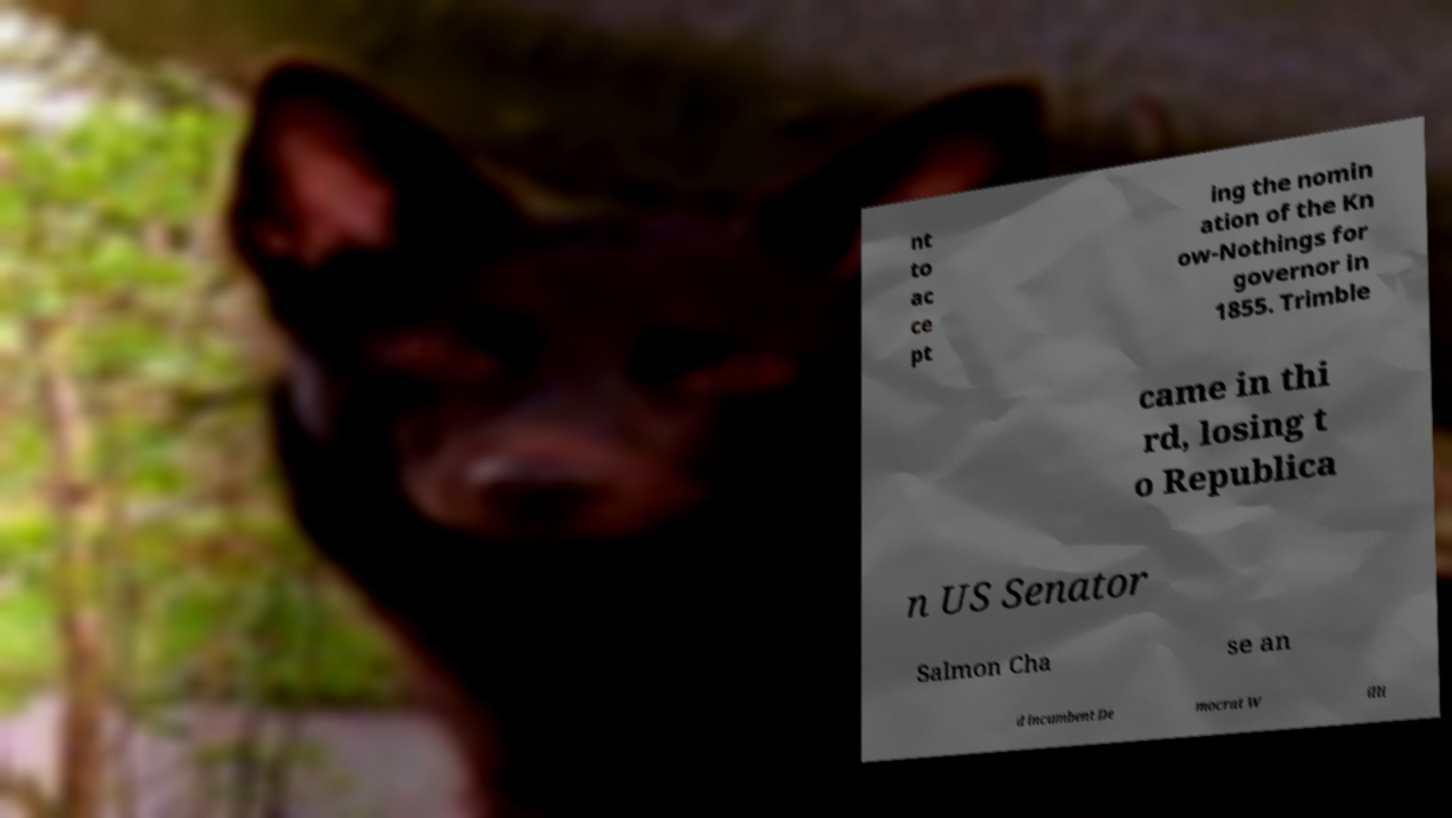Can you accurately transcribe the text from the provided image for me? nt to ac ce pt ing the nomin ation of the Kn ow-Nothings for governor in 1855. Trimble came in thi rd, losing t o Republica n US Senator Salmon Cha se an d incumbent De mocrat W illi 